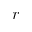<formula> <loc_0><loc_0><loc_500><loc_500>r</formula> 